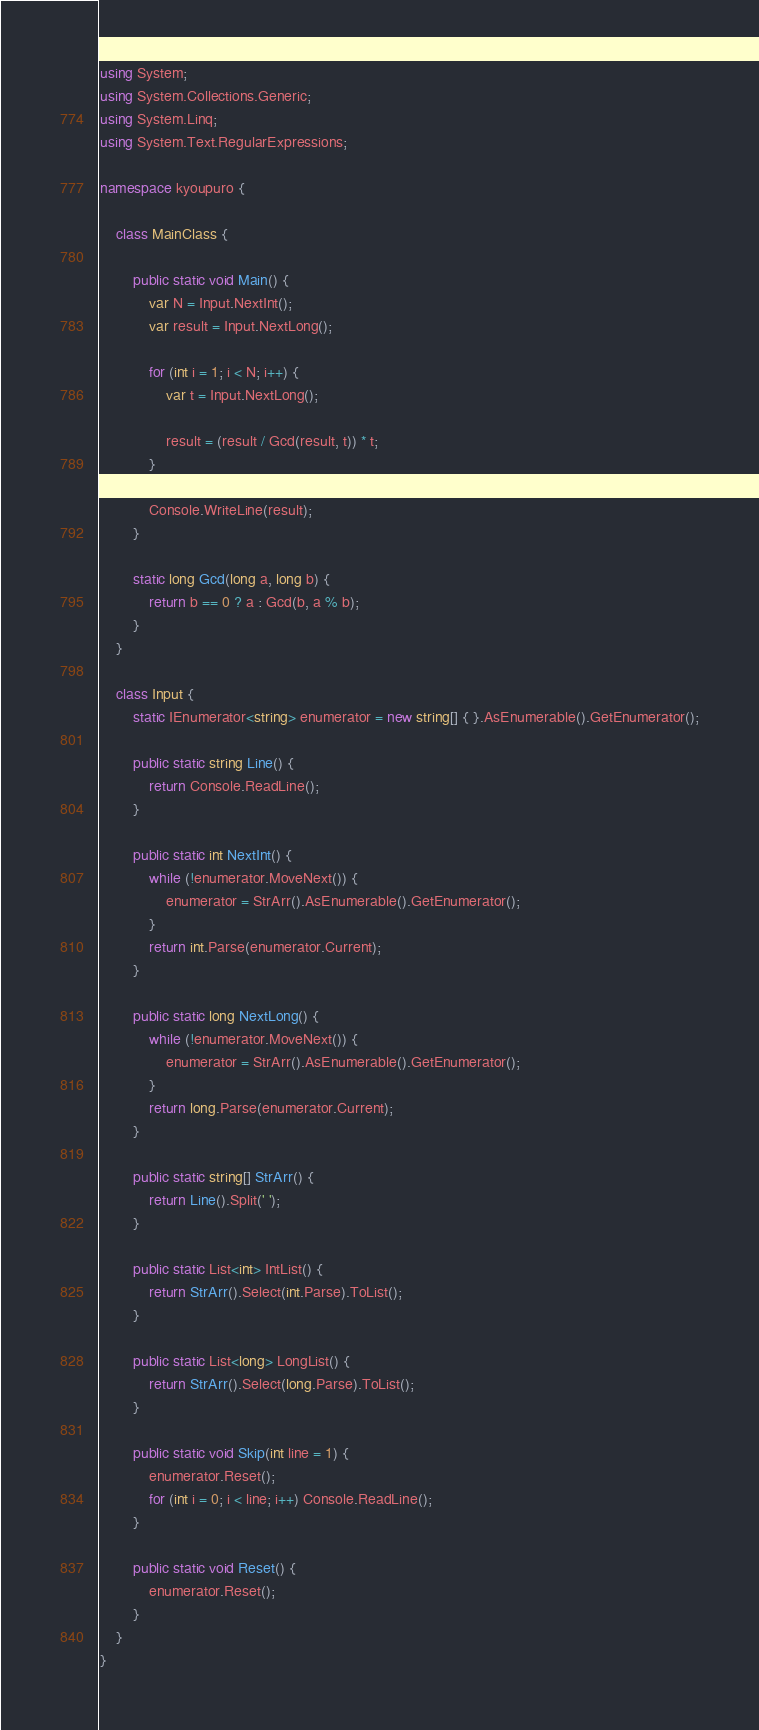Convert code to text. <code><loc_0><loc_0><loc_500><loc_500><_C#_>using System;
using System.Collections.Generic;
using System.Linq;
using System.Text.RegularExpressions;

namespace kyoupuro {

    class MainClass {

        public static void Main() {
            var N = Input.NextInt();
            var result = Input.NextLong();

            for (int i = 1; i < N; i++) {
                var t = Input.NextLong();

                result = (result / Gcd(result, t)) * t;
            }

            Console.WriteLine(result);
        }

        static long Gcd(long a, long b) {
            return b == 0 ? a : Gcd(b, a % b);
        }
    }

    class Input {
        static IEnumerator<string> enumerator = new string[] { }.AsEnumerable().GetEnumerator();

        public static string Line() {
            return Console.ReadLine();
        }

        public static int NextInt() {
            while (!enumerator.MoveNext()) {
                enumerator = StrArr().AsEnumerable().GetEnumerator();
            }
            return int.Parse(enumerator.Current);
        }

        public static long NextLong() {
            while (!enumerator.MoveNext()) {
                enumerator = StrArr().AsEnumerable().GetEnumerator();
            }
            return long.Parse(enumerator.Current);
        }

        public static string[] StrArr() {
            return Line().Split(' ');
        }

        public static List<int> IntList() {
            return StrArr().Select(int.Parse).ToList();
        }

        public static List<long> LongList() {
            return StrArr().Select(long.Parse).ToList();
        }

        public static void Skip(int line = 1) {
            enumerator.Reset();
            for (int i = 0; i < line; i++) Console.ReadLine();
        }

        public static void Reset() {
            enumerator.Reset();
        }
    }
}</code> 